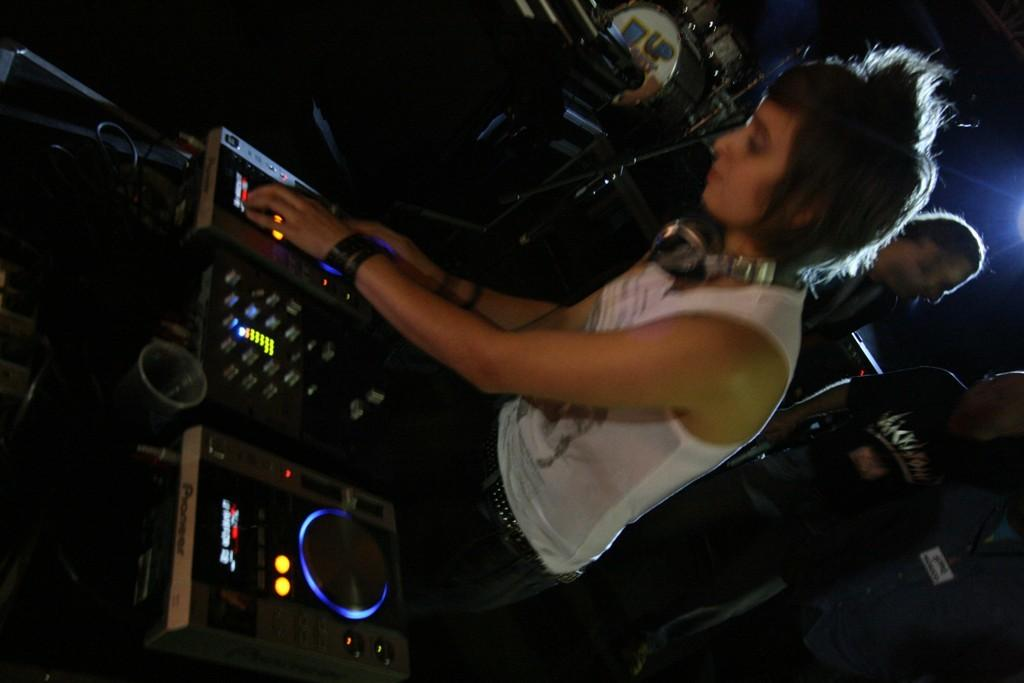Who is the main subject in the image? There is a woman in the image. What is the woman doing in the image? The woman is controlling a disc jack. Are there any other people in the image besides the woman? Yes, there are two men on the right side of the image. What type of tax is being discussed by the woman and the two men in the image? There is no indication in the image that a tax discussion is taking place. 